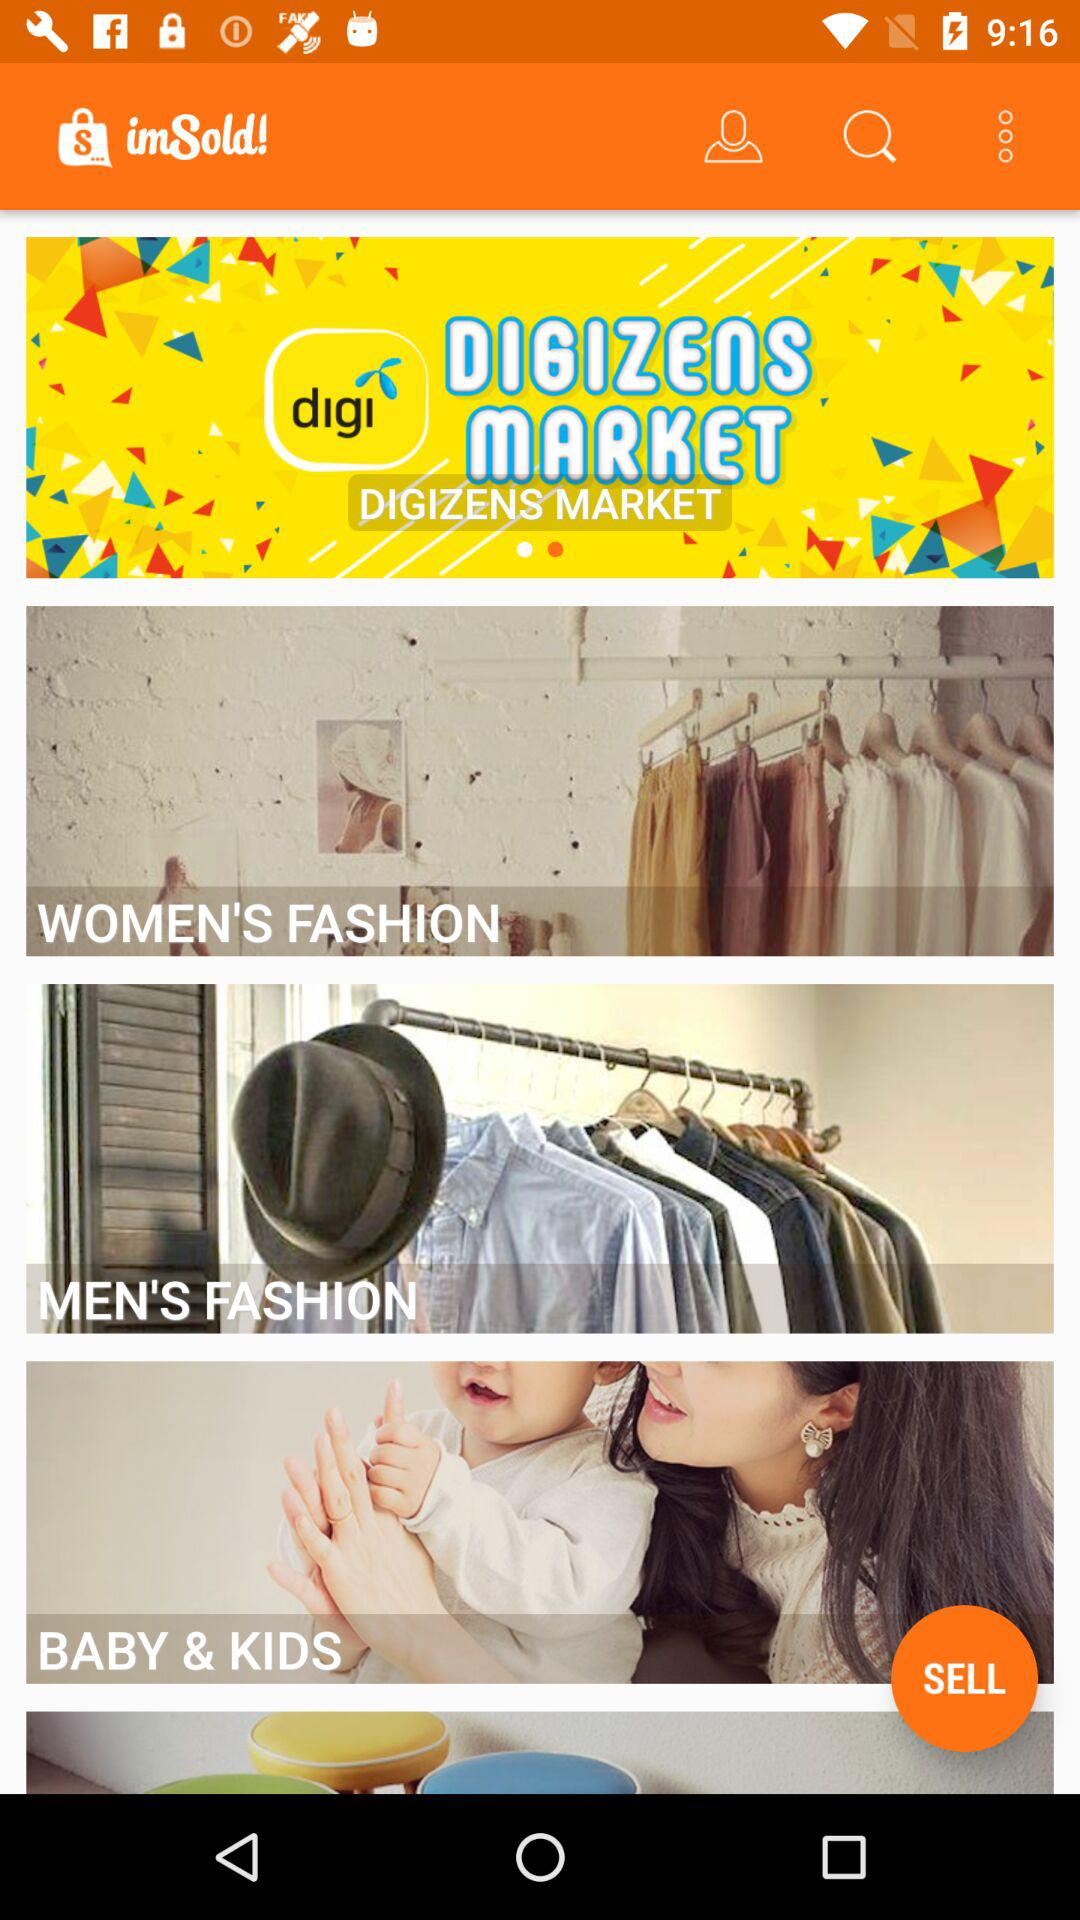Which payment method will the user use?
When the provided information is insufficient, respond with <no answer>. <no answer> 